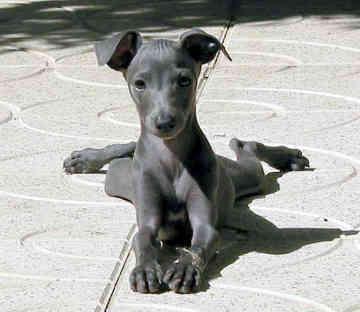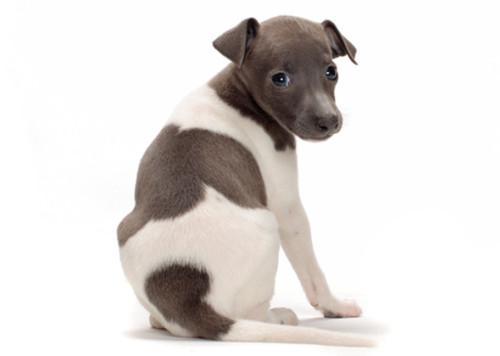The first image is the image on the left, the second image is the image on the right. Given the left and right images, does the statement "there is a solid gray dog with no white patches in one of the images." hold true? Answer yes or no. Yes. 